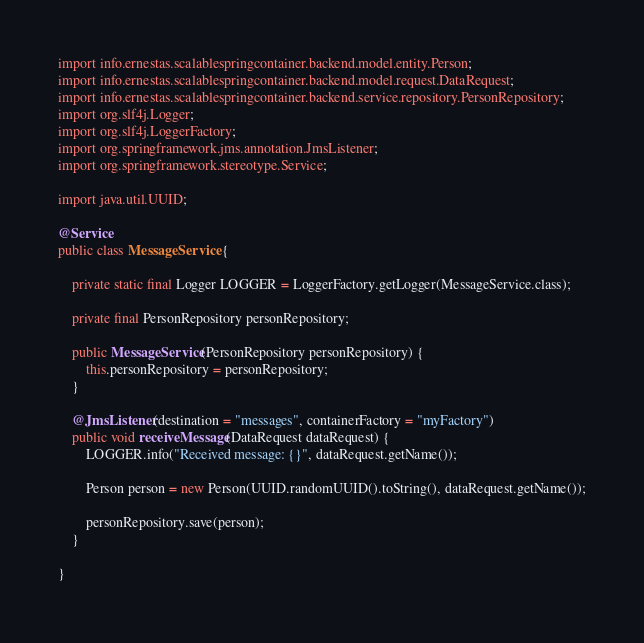Convert code to text. <code><loc_0><loc_0><loc_500><loc_500><_Java_>import info.ernestas.scalablespringcontainer.backend.model.entity.Person;
import info.ernestas.scalablespringcontainer.backend.model.request.DataRequest;
import info.ernestas.scalablespringcontainer.backend.service.repository.PersonRepository;
import org.slf4j.Logger;
import org.slf4j.LoggerFactory;
import org.springframework.jms.annotation.JmsListener;
import org.springframework.stereotype.Service;

import java.util.UUID;

@Service
public class MessageService {

    private static final Logger LOGGER = LoggerFactory.getLogger(MessageService.class);

    private final PersonRepository personRepository;

    public MessageService(PersonRepository personRepository) {
        this.personRepository = personRepository;
    }

    @JmsListener(destination = "messages", containerFactory = "myFactory")
    public void receiveMessage(DataRequest dataRequest) {
        LOGGER.info("Received message: {}", dataRequest.getName());

        Person person = new Person(UUID.randomUUID().toString(), dataRequest.getName());

        personRepository.save(person);
    }

}
</code> 